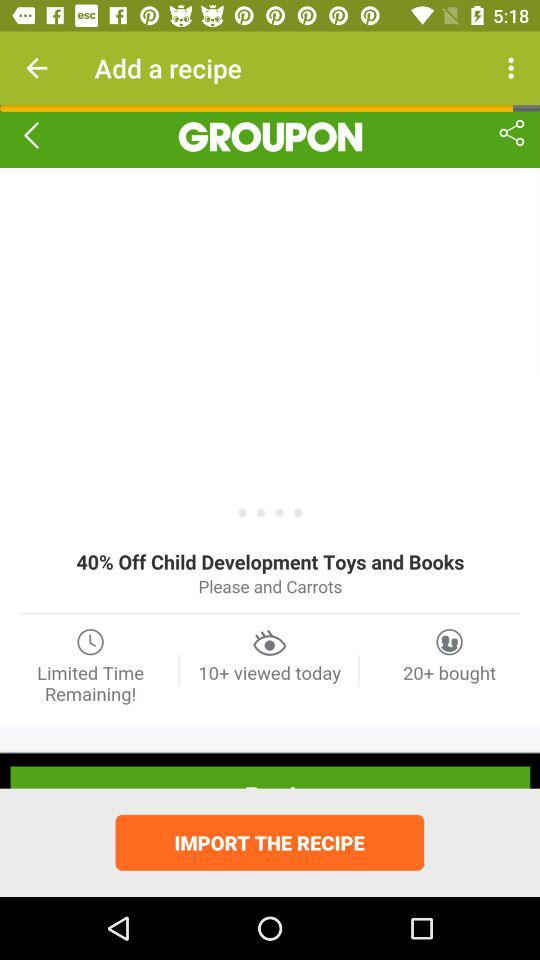How many people viewed the recipe today? The people who reviewed the recipe are 10+. 